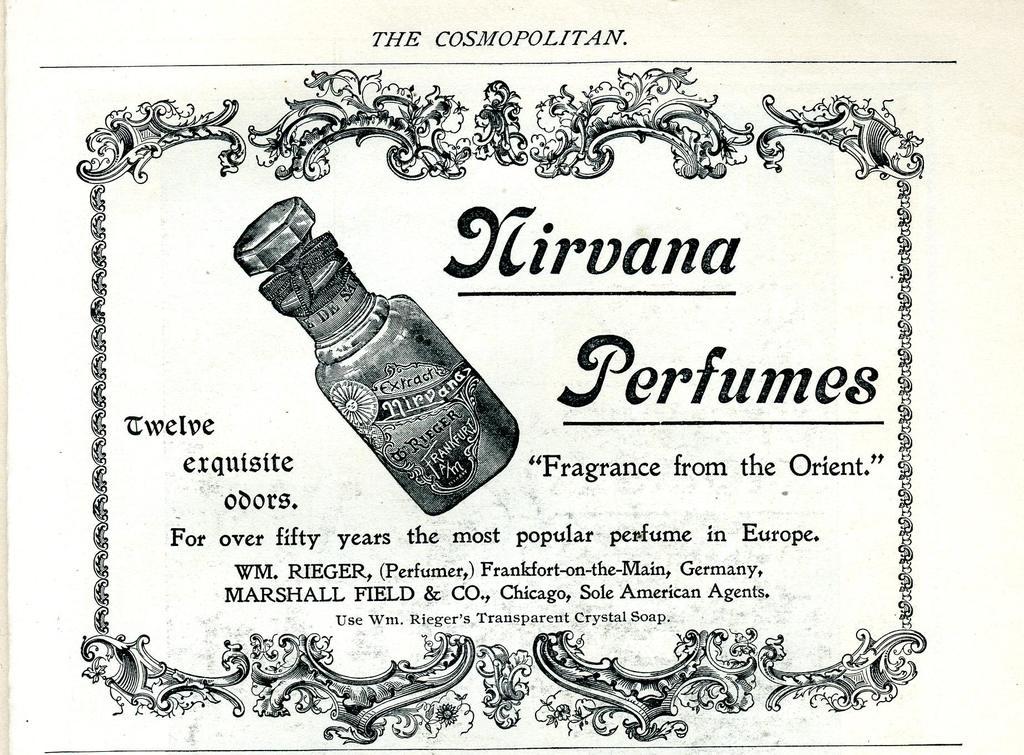Where is the fragrance from?
Make the answer very short. The orient. What is the name of the perfume?
Offer a terse response. Nirvana. 